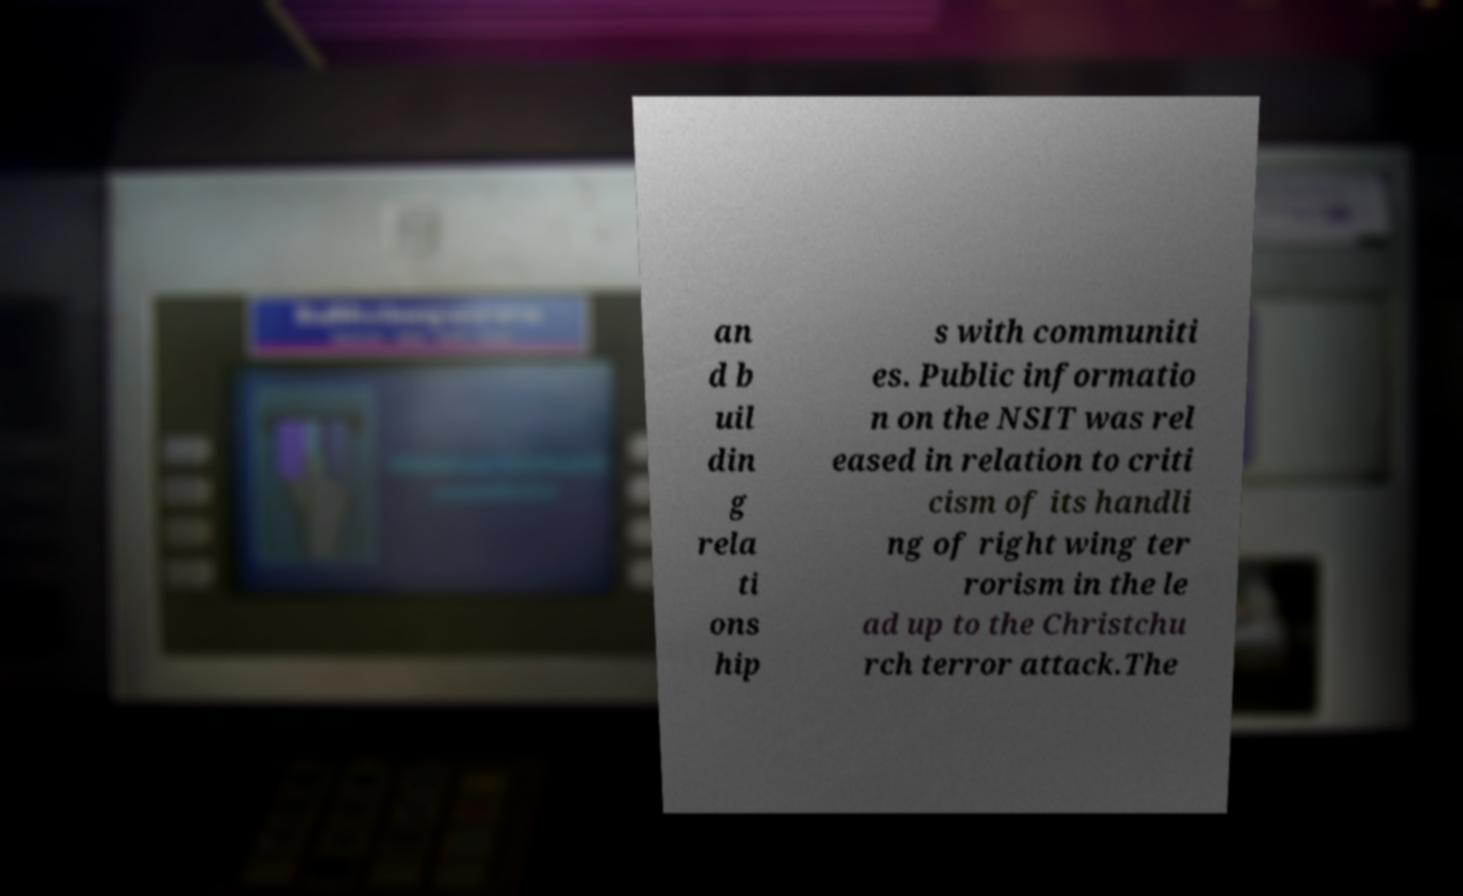Please identify and transcribe the text found in this image. an d b uil din g rela ti ons hip s with communiti es. Public informatio n on the NSIT was rel eased in relation to criti cism of its handli ng of right wing ter rorism in the le ad up to the Christchu rch terror attack.The 